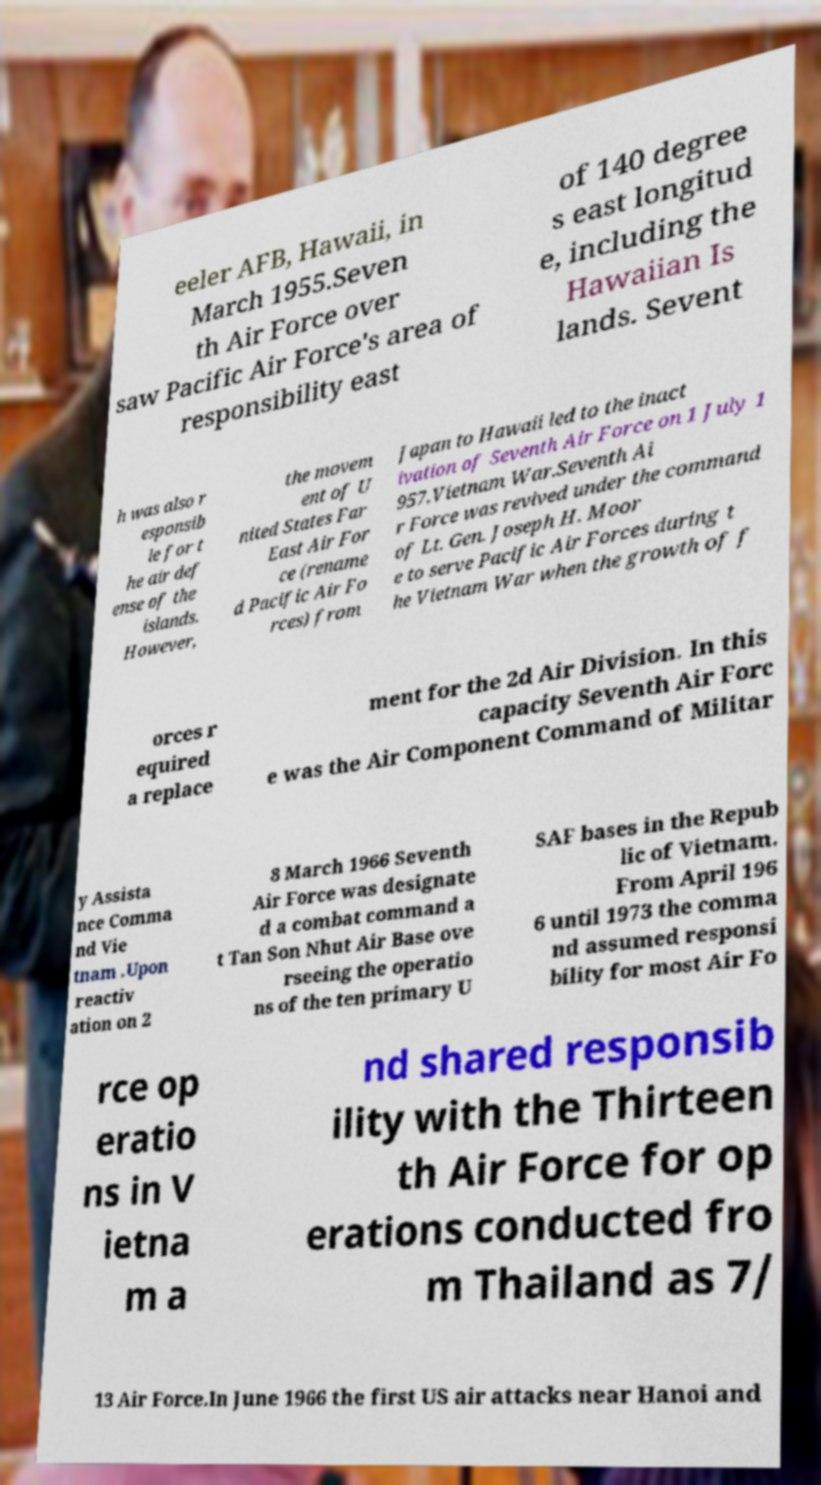Can you read and provide the text displayed in the image?This photo seems to have some interesting text. Can you extract and type it out for me? eeler AFB, Hawaii, in March 1955.Seven th Air Force over saw Pacific Air Force's area of responsibility east of 140 degree s east longitud e, including the Hawaiian Is lands. Sevent h was also r esponsib le for t he air def ense of the islands. However, the movem ent of U nited States Far East Air For ce (rename d Pacific Air Fo rces) from Japan to Hawaii led to the inact ivation of Seventh Air Force on 1 July 1 957.Vietnam War.Seventh Ai r Force was revived under the command of Lt. Gen. Joseph H. Moor e to serve Pacific Air Forces during t he Vietnam War when the growth of f orces r equired a replace ment for the 2d Air Division. In this capacity Seventh Air Forc e was the Air Component Command of Militar y Assista nce Comma nd Vie tnam .Upon reactiv ation on 2 8 March 1966 Seventh Air Force was designate d a combat command a t Tan Son Nhut Air Base ove rseeing the operatio ns of the ten primary U SAF bases in the Repub lic of Vietnam. From April 196 6 until 1973 the comma nd assumed responsi bility for most Air Fo rce op eratio ns in V ietna m a nd shared responsib ility with the Thirteen th Air Force for op erations conducted fro m Thailand as 7/ 13 Air Force.In June 1966 the first US air attacks near Hanoi and 